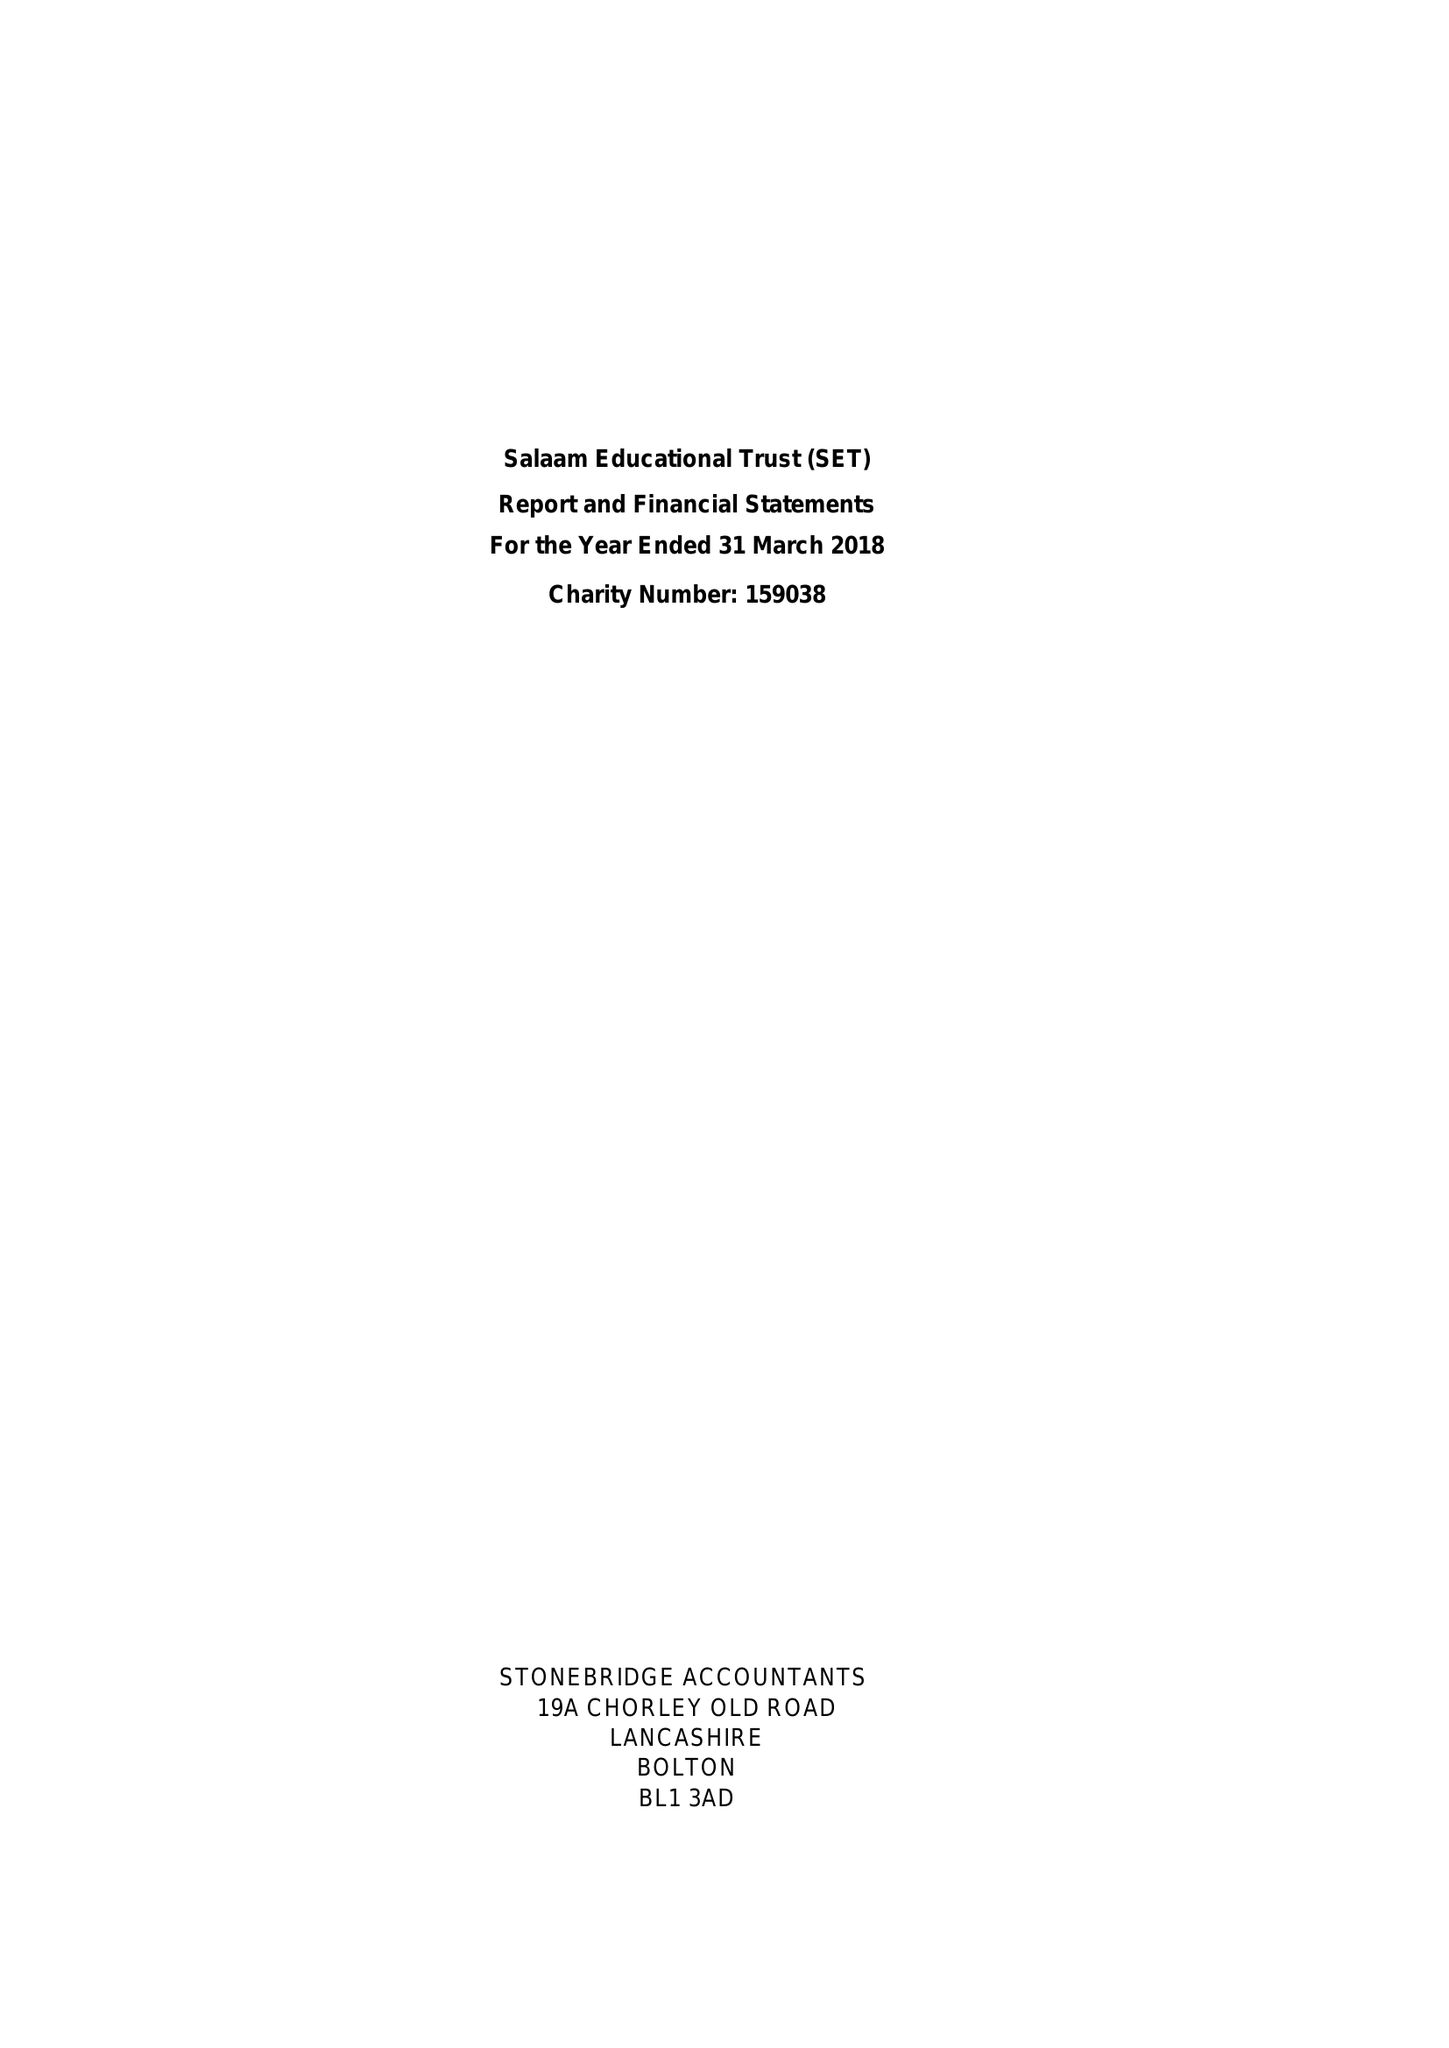What is the value for the income_annually_in_british_pounds?
Answer the question using a single word or phrase. 68765.00 